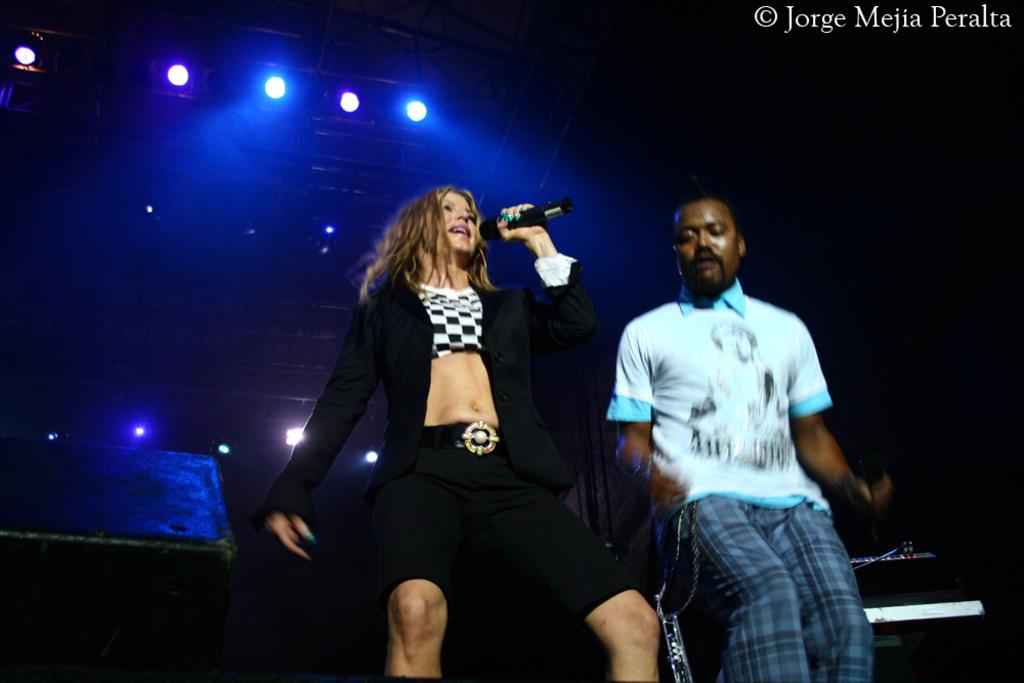Who is the main subject in the image? There is a woman in the middle of the image. What is the woman holding in the image? The woman is holding a microphone. Who is standing next to the woman? There is a man beside the woman. What is the man doing in the image? The man is dancing. What can be seen at the top of the image? There are lights visible at the top of the image. How many dogs are present in the image? There are no dogs present in the image. What type of hand is shown holding the microphone? The image does not show a hand holding the microphone; it only shows the woman holding the microphone. 